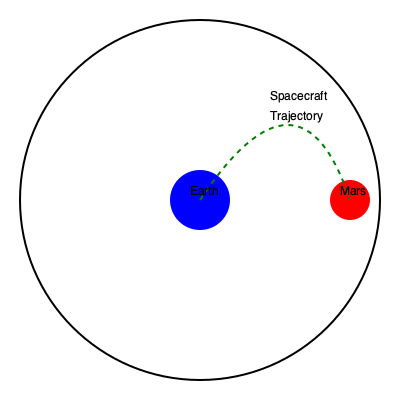As a space enthusiast and actor preparing for a role as an astronaut in an upcoming sci-fi blockbuster, you're studying orbital mechanics. Consider a spacecraft traveling from Earth to Mars using a Hohmann transfer orbit. If the semi-major axis of Earth's orbit is $a_E = 1$ AU and Mars' orbit is $a_M = 1.52$ AU, what is the time of flight (in days) for the spacecraft to reach Mars, assuming circular and coplanar orbits? To solve this problem, we'll follow these steps:

1) The semi-major axis of the transfer orbit ($a_T$) is the average of the radii of the two orbits:

   $a_T = \frac{r_E + r_M}{2} = \frac{a_E + a_M}{2} = \frac{1 + 1.52}{2} = 1.26$ AU

2) The period of the transfer orbit is given by Kepler's Third Law:

   $T^2 = 4\pi^2 \frac{a_T^3}{GM_\odot}$

   Where $G$ is the gravitational constant and $M_\odot$ is the mass of the Sun.

3) We can use Earth's orbital period (1 year) to simplify:

   $1^2 = 4\pi^2 \frac{1^3}{GM_\odot}$

   $GM_\odot = 4\pi^2$

4) Substituting this into the period equation for the transfer orbit:

   $T^2 = 4\pi^2 \frac{a_T^3}{4\pi^2} = a_T^3 = 1.26^3 = 2$

   $T = \sqrt{2} = 1.414$ years

5) The spacecraft travels only half of this orbit to reach Mars:

   Time of flight = $\frac{T}{2} = \frac{1.414}{2} = 0.707$ years

6) Convert to days:

   $0.707 \times 365.25 = 258.23$ days

Therefore, the time of flight from Earth to Mars using a Hohmann transfer orbit is approximately 258 days.
Answer: 258 days 